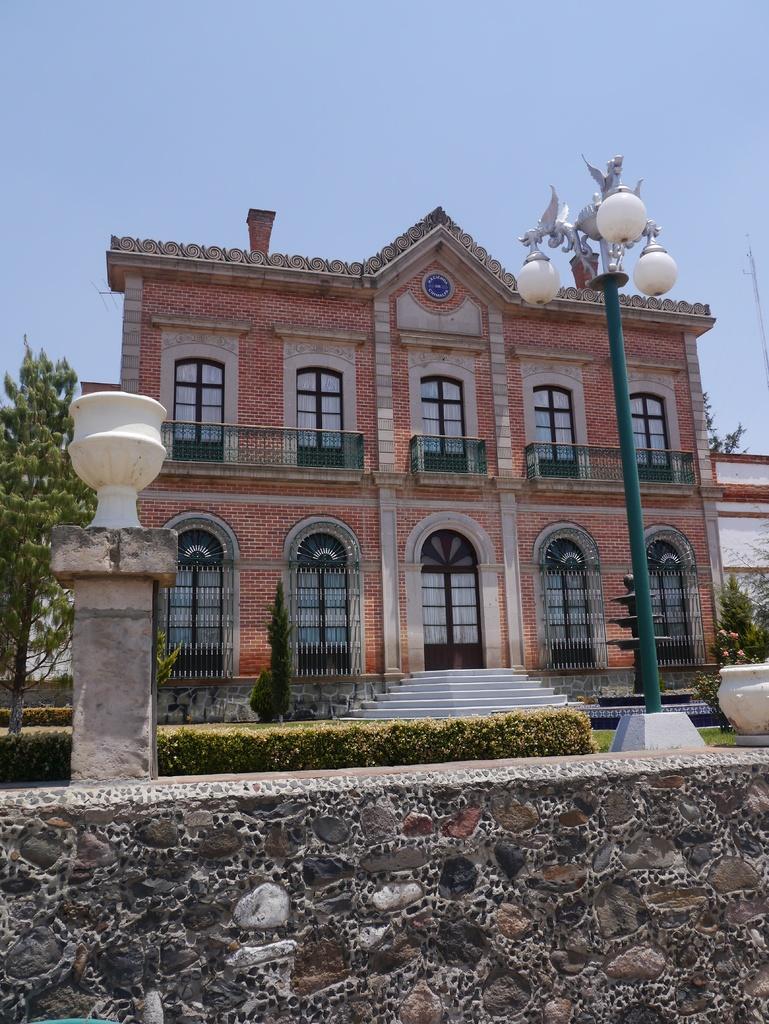Describe this image in one or two sentences. At the bottom of the image we can see a wall. Behind the wall we can see some plants, poles, trees and building. At the top of the image we can see the sky. 